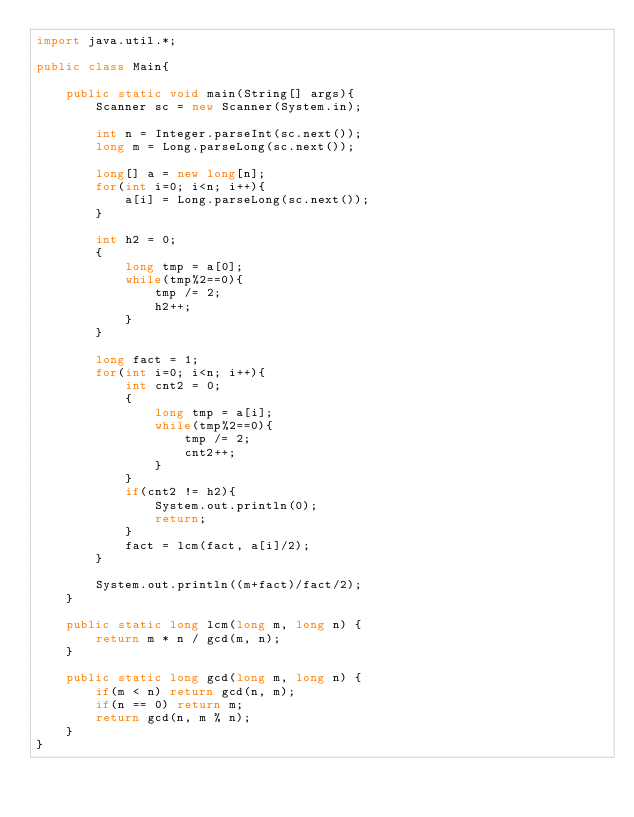Convert code to text. <code><loc_0><loc_0><loc_500><loc_500><_Java_>import java.util.*;

public class Main{
    
    public static void main(String[] args){
        Scanner sc = new Scanner(System.in);
        
        int n = Integer.parseInt(sc.next());
        long m = Long.parseLong(sc.next());
        
        long[] a = new long[n];
        for(int i=0; i<n; i++){
            a[i] = Long.parseLong(sc.next());
        }
        
        int h2 = 0;
        {
            long tmp = a[0];
            while(tmp%2==0){
                tmp /= 2;
                h2++;
            }
        }
        
        long fact = 1;
        for(int i=0; i<n; i++){
            int cnt2 = 0;
            {
                long tmp = a[i];
                while(tmp%2==0){
                    tmp /= 2;
                    cnt2++;
                }
            }
            if(cnt2 != h2){
                System.out.println(0);
                return;
            }
            fact = lcm(fact, a[i]/2);
        }
        
        System.out.println((m+fact)/fact/2);
    }
    
    public static long lcm(long m, long n) {
        return m * n / gcd(m, n);
    }
    
    public static long gcd(long m, long n) {
        if(m < n) return gcd(n, m);
        if(n == 0) return m;
        return gcd(n, m % n);
    }
}
</code> 